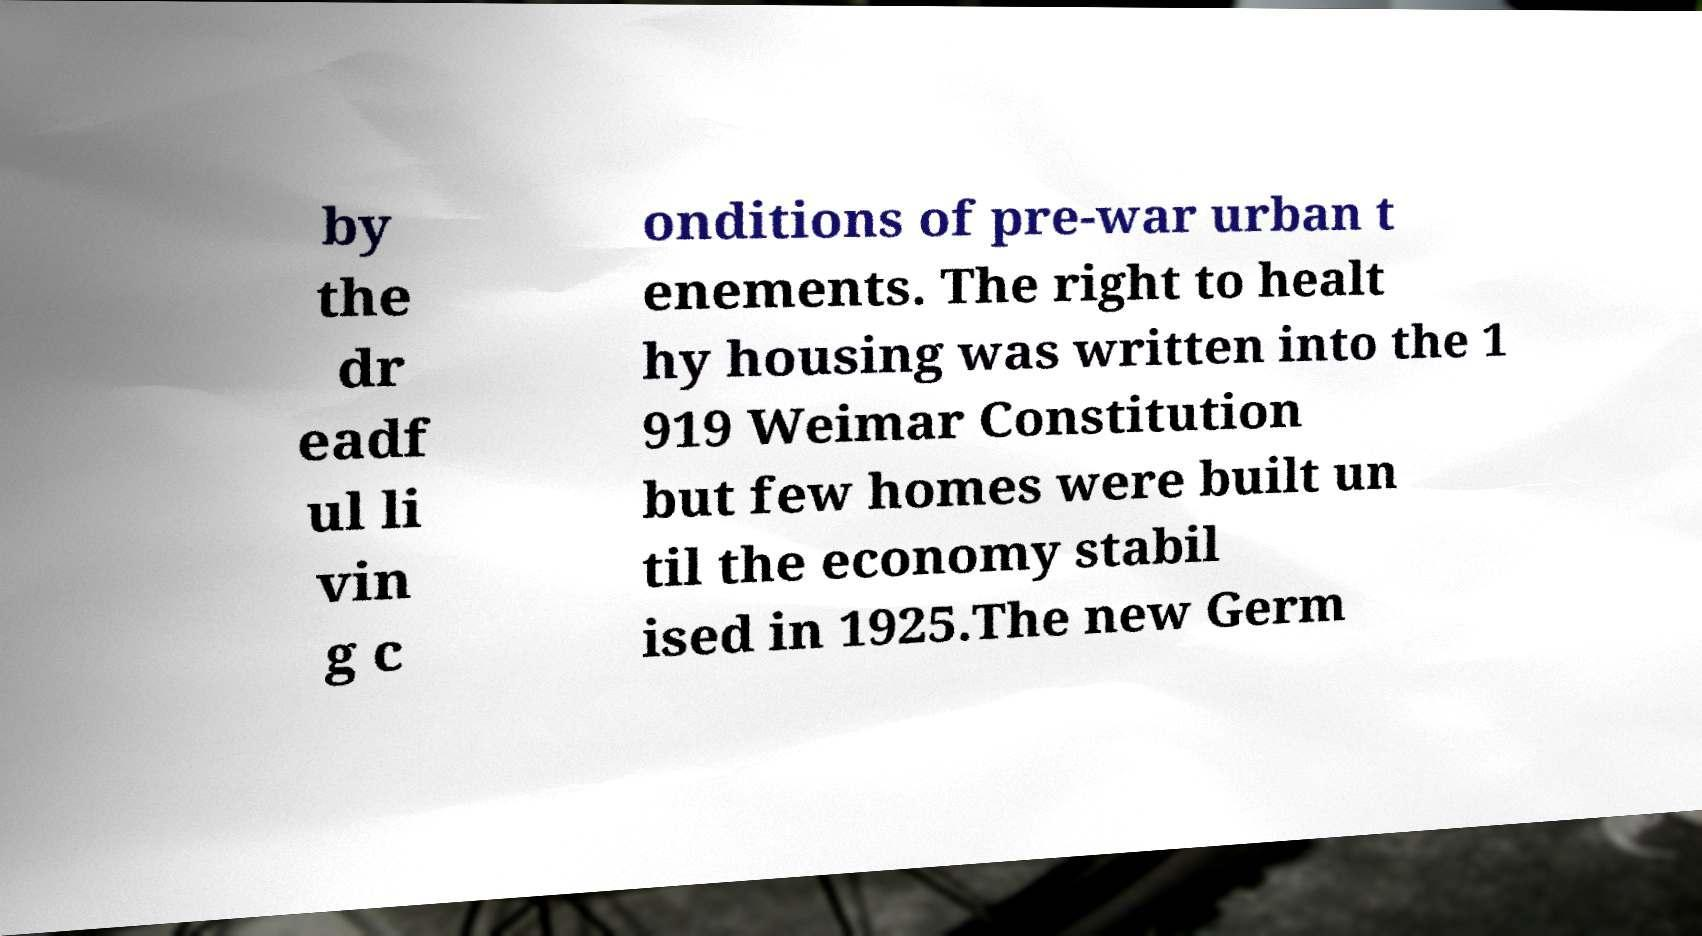Can you read and provide the text displayed in the image?This photo seems to have some interesting text. Can you extract and type it out for me? by the dr eadf ul li vin g c onditions of pre-war urban t enements. The right to healt hy housing was written into the 1 919 Weimar Constitution but few homes were built un til the economy stabil ised in 1925.The new Germ 